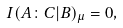Convert formula to latex. <formula><loc_0><loc_0><loc_500><loc_500>I ( A \colon C | B ) _ { \mu } = 0 ,</formula> 